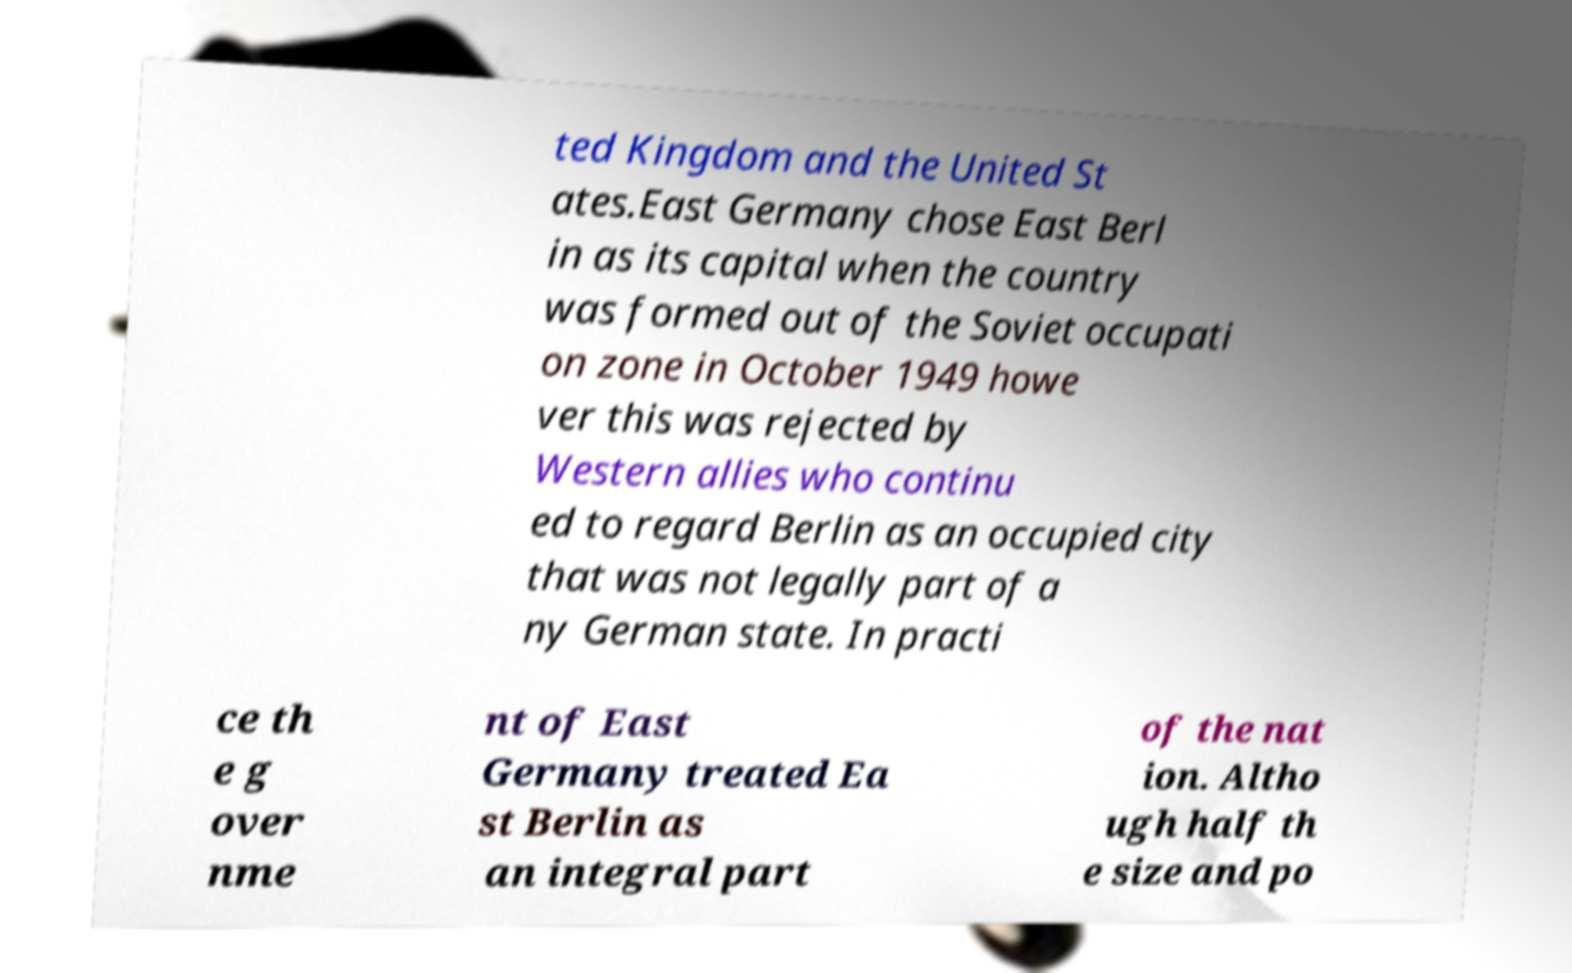Can you read and provide the text displayed in the image?This photo seems to have some interesting text. Can you extract and type it out for me? ted Kingdom and the United St ates.East Germany chose East Berl in as its capital when the country was formed out of the Soviet occupati on zone in October 1949 howe ver this was rejected by Western allies who continu ed to regard Berlin as an occupied city that was not legally part of a ny German state. In practi ce th e g over nme nt of East Germany treated Ea st Berlin as an integral part of the nat ion. Altho ugh half th e size and po 